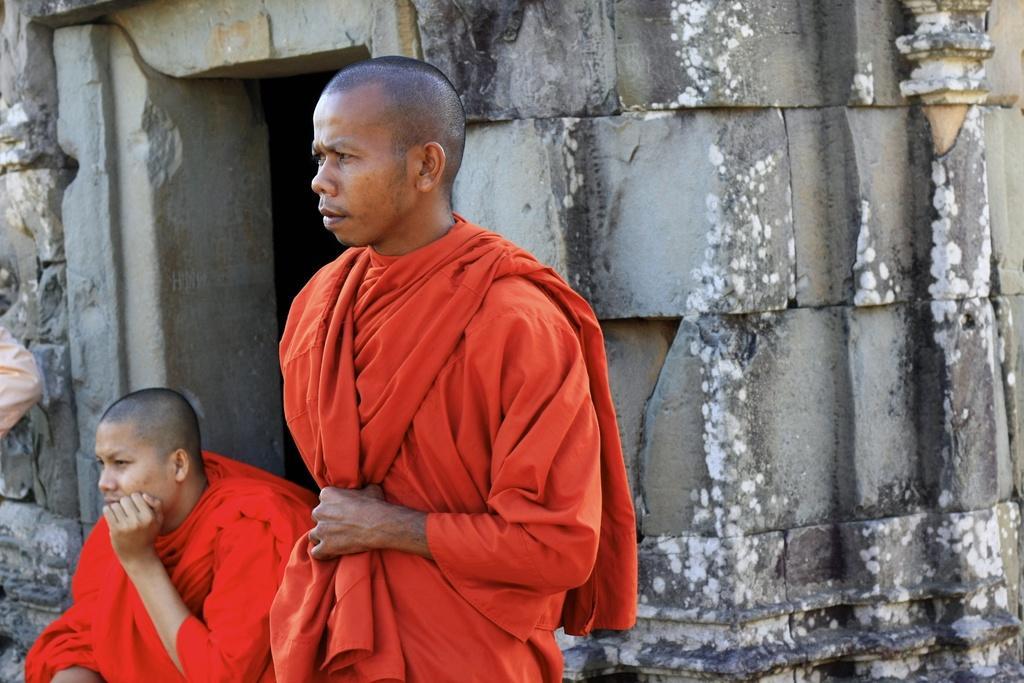Please provide a concise description of this image. In this image we can see some persons. In the background of the image there is an entrance and a wall. On the left side of the image it looks like a person. 